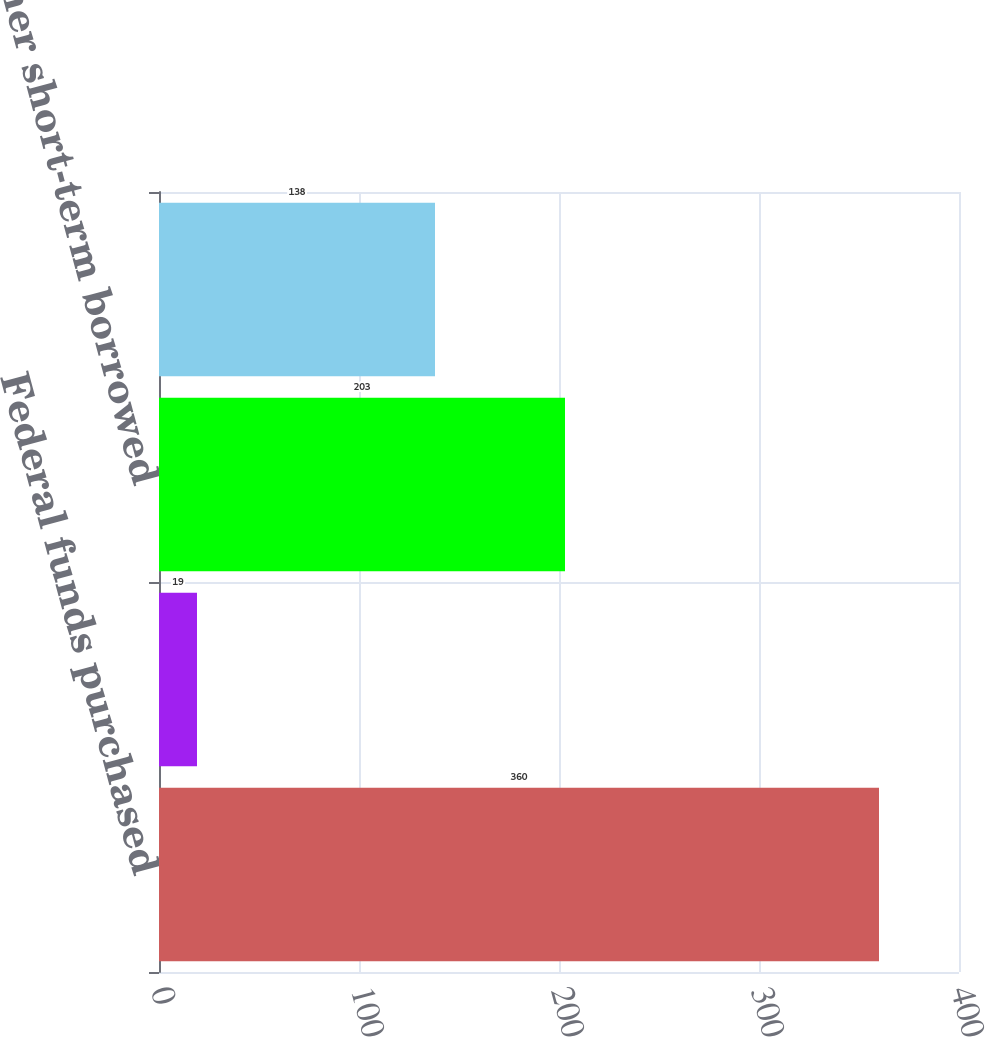Convert chart to OTSL. <chart><loc_0><loc_0><loc_500><loc_500><bar_chart><fcel>Federal funds purchased<fcel>Securities sold under<fcel>Other short-term borrowed<fcel>Total short-term borrowed<nl><fcel>360<fcel>19<fcel>203<fcel>138<nl></chart> 